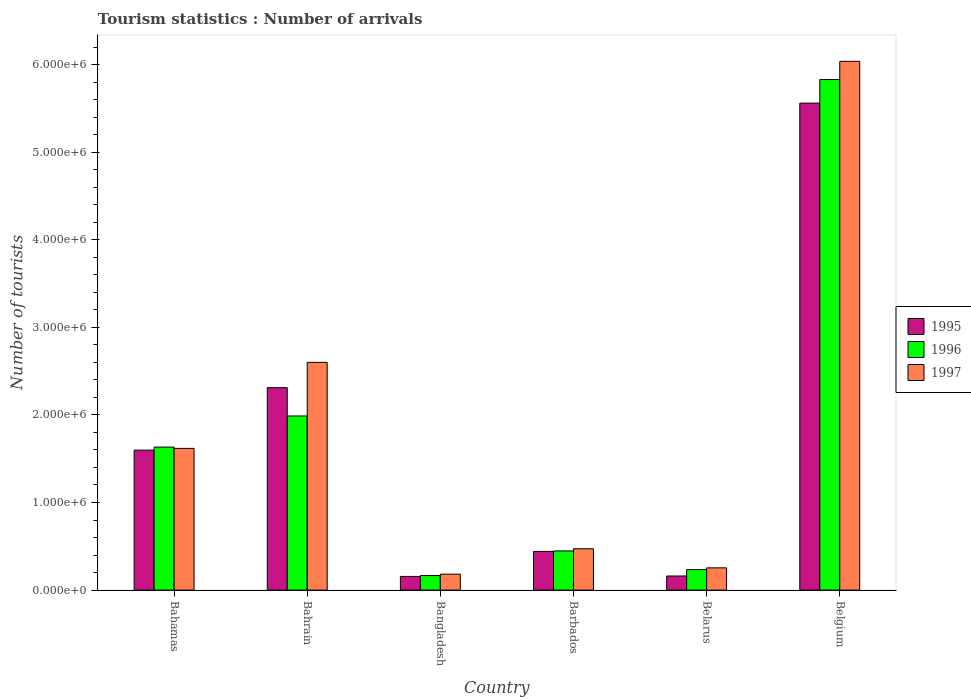Are the number of bars per tick equal to the number of legend labels?
Make the answer very short. Yes. Are the number of bars on each tick of the X-axis equal?
Offer a very short reply. Yes. How many bars are there on the 5th tick from the left?
Your answer should be very brief. 3. What is the label of the 2nd group of bars from the left?
Your response must be concise. Bahrain. In how many cases, is the number of bars for a given country not equal to the number of legend labels?
Offer a very short reply. 0. What is the number of tourist arrivals in 1995 in Bangladesh?
Offer a terse response. 1.56e+05. Across all countries, what is the maximum number of tourist arrivals in 1995?
Offer a terse response. 5.56e+06. Across all countries, what is the minimum number of tourist arrivals in 1996?
Give a very brief answer. 1.66e+05. In which country was the number of tourist arrivals in 1995 minimum?
Your response must be concise. Bangladesh. What is the total number of tourist arrivals in 1997 in the graph?
Your answer should be very brief. 1.12e+07. What is the difference between the number of tourist arrivals in 1997 in Barbados and that in Belgium?
Offer a terse response. -5.56e+06. What is the difference between the number of tourist arrivals in 1995 in Bahrain and the number of tourist arrivals in 1997 in Barbados?
Your response must be concise. 1.84e+06. What is the average number of tourist arrivals in 1997 per country?
Ensure brevity in your answer.  1.86e+06. What is the difference between the number of tourist arrivals of/in 1995 and number of tourist arrivals of/in 1997 in Barbados?
Keep it short and to the point. -3.00e+04. In how many countries, is the number of tourist arrivals in 1996 greater than 5800000?
Provide a short and direct response. 1. What is the ratio of the number of tourist arrivals in 1997 in Barbados to that in Belarus?
Ensure brevity in your answer.  1.86. What is the difference between the highest and the second highest number of tourist arrivals in 1996?
Provide a succinct answer. 4.20e+06. What is the difference between the highest and the lowest number of tourist arrivals in 1996?
Provide a short and direct response. 5.66e+06. What does the 2nd bar from the left in Bahamas represents?
Give a very brief answer. 1996. Is it the case that in every country, the sum of the number of tourist arrivals in 1996 and number of tourist arrivals in 1995 is greater than the number of tourist arrivals in 1997?
Your response must be concise. Yes. How many countries are there in the graph?
Provide a short and direct response. 6. What is the difference between two consecutive major ticks on the Y-axis?
Give a very brief answer. 1.00e+06. Does the graph contain grids?
Your answer should be compact. No. Where does the legend appear in the graph?
Your answer should be compact. Center right. What is the title of the graph?
Offer a very short reply. Tourism statistics : Number of arrivals. Does "1981" appear as one of the legend labels in the graph?
Provide a succinct answer. No. What is the label or title of the Y-axis?
Your response must be concise. Number of tourists. What is the Number of tourists of 1995 in Bahamas?
Provide a short and direct response. 1.60e+06. What is the Number of tourists of 1996 in Bahamas?
Give a very brief answer. 1.63e+06. What is the Number of tourists of 1997 in Bahamas?
Offer a terse response. 1.62e+06. What is the Number of tourists of 1995 in Bahrain?
Provide a succinct answer. 2.31e+06. What is the Number of tourists in 1996 in Bahrain?
Your answer should be compact. 1.99e+06. What is the Number of tourists of 1997 in Bahrain?
Offer a very short reply. 2.60e+06. What is the Number of tourists of 1995 in Bangladesh?
Provide a succinct answer. 1.56e+05. What is the Number of tourists of 1996 in Bangladesh?
Keep it short and to the point. 1.66e+05. What is the Number of tourists in 1997 in Bangladesh?
Your answer should be very brief. 1.82e+05. What is the Number of tourists of 1995 in Barbados?
Your response must be concise. 4.42e+05. What is the Number of tourists in 1996 in Barbados?
Provide a succinct answer. 4.47e+05. What is the Number of tourists in 1997 in Barbados?
Offer a very short reply. 4.72e+05. What is the Number of tourists of 1995 in Belarus?
Ensure brevity in your answer.  1.61e+05. What is the Number of tourists in 1996 in Belarus?
Give a very brief answer. 2.34e+05. What is the Number of tourists in 1997 in Belarus?
Your answer should be very brief. 2.54e+05. What is the Number of tourists in 1995 in Belgium?
Provide a succinct answer. 5.56e+06. What is the Number of tourists of 1996 in Belgium?
Your response must be concise. 5.83e+06. What is the Number of tourists of 1997 in Belgium?
Offer a very short reply. 6.04e+06. Across all countries, what is the maximum Number of tourists in 1995?
Provide a short and direct response. 5.56e+06. Across all countries, what is the maximum Number of tourists of 1996?
Offer a very short reply. 5.83e+06. Across all countries, what is the maximum Number of tourists of 1997?
Provide a succinct answer. 6.04e+06. Across all countries, what is the minimum Number of tourists of 1995?
Offer a very short reply. 1.56e+05. Across all countries, what is the minimum Number of tourists in 1996?
Your answer should be very brief. 1.66e+05. Across all countries, what is the minimum Number of tourists in 1997?
Offer a very short reply. 1.82e+05. What is the total Number of tourists of 1995 in the graph?
Your answer should be compact. 1.02e+07. What is the total Number of tourists of 1996 in the graph?
Offer a very short reply. 1.03e+07. What is the total Number of tourists in 1997 in the graph?
Your answer should be very brief. 1.12e+07. What is the difference between the Number of tourists of 1995 in Bahamas and that in Bahrain?
Keep it short and to the point. -7.13e+05. What is the difference between the Number of tourists of 1996 in Bahamas and that in Bahrain?
Your answer should be compact. -3.55e+05. What is the difference between the Number of tourists in 1997 in Bahamas and that in Bahrain?
Provide a succinct answer. -9.82e+05. What is the difference between the Number of tourists of 1995 in Bahamas and that in Bangladesh?
Give a very brief answer. 1.44e+06. What is the difference between the Number of tourists in 1996 in Bahamas and that in Bangladesh?
Ensure brevity in your answer.  1.47e+06. What is the difference between the Number of tourists of 1997 in Bahamas and that in Bangladesh?
Provide a succinct answer. 1.44e+06. What is the difference between the Number of tourists of 1995 in Bahamas and that in Barbados?
Your answer should be compact. 1.16e+06. What is the difference between the Number of tourists of 1996 in Bahamas and that in Barbados?
Keep it short and to the point. 1.19e+06. What is the difference between the Number of tourists in 1997 in Bahamas and that in Barbados?
Your answer should be very brief. 1.15e+06. What is the difference between the Number of tourists in 1995 in Bahamas and that in Belarus?
Your answer should be compact. 1.44e+06. What is the difference between the Number of tourists of 1996 in Bahamas and that in Belarus?
Your response must be concise. 1.40e+06. What is the difference between the Number of tourists of 1997 in Bahamas and that in Belarus?
Your response must be concise. 1.36e+06. What is the difference between the Number of tourists in 1995 in Bahamas and that in Belgium?
Provide a succinct answer. -3.96e+06. What is the difference between the Number of tourists of 1996 in Bahamas and that in Belgium?
Give a very brief answer. -4.20e+06. What is the difference between the Number of tourists in 1997 in Bahamas and that in Belgium?
Keep it short and to the point. -4.42e+06. What is the difference between the Number of tourists in 1995 in Bahrain and that in Bangladesh?
Offer a terse response. 2.16e+06. What is the difference between the Number of tourists in 1996 in Bahrain and that in Bangladesh?
Your answer should be compact. 1.82e+06. What is the difference between the Number of tourists in 1997 in Bahrain and that in Bangladesh?
Keep it short and to the point. 2.42e+06. What is the difference between the Number of tourists in 1995 in Bahrain and that in Barbados?
Your answer should be compact. 1.87e+06. What is the difference between the Number of tourists in 1996 in Bahrain and that in Barbados?
Keep it short and to the point. 1.54e+06. What is the difference between the Number of tourists in 1997 in Bahrain and that in Barbados?
Offer a terse response. 2.13e+06. What is the difference between the Number of tourists of 1995 in Bahrain and that in Belarus?
Your answer should be compact. 2.15e+06. What is the difference between the Number of tourists of 1996 in Bahrain and that in Belarus?
Your answer should be very brief. 1.75e+06. What is the difference between the Number of tourists of 1997 in Bahrain and that in Belarus?
Provide a succinct answer. 2.35e+06. What is the difference between the Number of tourists in 1995 in Bahrain and that in Belgium?
Give a very brief answer. -3.25e+06. What is the difference between the Number of tourists in 1996 in Bahrain and that in Belgium?
Make the answer very short. -3.84e+06. What is the difference between the Number of tourists of 1997 in Bahrain and that in Belgium?
Give a very brief answer. -3.44e+06. What is the difference between the Number of tourists in 1995 in Bangladesh and that in Barbados?
Make the answer very short. -2.86e+05. What is the difference between the Number of tourists in 1996 in Bangladesh and that in Barbados?
Offer a terse response. -2.81e+05. What is the difference between the Number of tourists of 1995 in Bangladesh and that in Belarus?
Offer a very short reply. -5000. What is the difference between the Number of tourists of 1996 in Bangladesh and that in Belarus?
Provide a succinct answer. -6.80e+04. What is the difference between the Number of tourists of 1997 in Bangladesh and that in Belarus?
Your answer should be very brief. -7.20e+04. What is the difference between the Number of tourists of 1995 in Bangladesh and that in Belgium?
Keep it short and to the point. -5.40e+06. What is the difference between the Number of tourists in 1996 in Bangladesh and that in Belgium?
Make the answer very short. -5.66e+06. What is the difference between the Number of tourists of 1997 in Bangladesh and that in Belgium?
Your answer should be very brief. -5.86e+06. What is the difference between the Number of tourists of 1995 in Barbados and that in Belarus?
Provide a short and direct response. 2.81e+05. What is the difference between the Number of tourists in 1996 in Barbados and that in Belarus?
Your response must be concise. 2.13e+05. What is the difference between the Number of tourists in 1997 in Barbados and that in Belarus?
Make the answer very short. 2.18e+05. What is the difference between the Number of tourists in 1995 in Barbados and that in Belgium?
Provide a succinct answer. -5.12e+06. What is the difference between the Number of tourists in 1996 in Barbados and that in Belgium?
Your response must be concise. -5.38e+06. What is the difference between the Number of tourists of 1997 in Barbados and that in Belgium?
Ensure brevity in your answer.  -5.56e+06. What is the difference between the Number of tourists in 1995 in Belarus and that in Belgium?
Provide a succinct answer. -5.40e+06. What is the difference between the Number of tourists of 1996 in Belarus and that in Belgium?
Offer a very short reply. -5.60e+06. What is the difference between the Number of tourists of 1997 in Belarus and that in Belgium?
Ensure brevity in your answer.  -5.78e+06. What is the difference between the Number of tourists in 1995 in Bahamas and the Number of tourists in 1996 in Bahrain?
Your response must be concise. -3.90e+05. What is the difference between the Number of tourists of 1995 in Bahamas and the Number of tourists of 1997 in Bahrain?
Offer a terse response. -1.00e+06. What is the difference between the Number of tourists in 1996 in Bahamas and the Number of tourists in 1997 in Bahrain?
Your answer should be compact. -9.67e+05. What is the difference between the Number of tourists in 1995 in Bahamas and the Number of tourists in 1996 in Bangladesh?
Keep it short and to the point. 1.43e+06. What is the difference between the Number of tourists of 1995 in Bahamas and the Number of tourists of 1997 in Bangladesh?
Your answer should be compact. 1.42e+06. What is the difference between the Number of tourists of 1996 in Bahamas and the Number of tourists of 1997 in Bangladesh?
Keep it short and to the point. 1.45e+06. What is the difference between the Number of tourists of 1995 in Bahamas and the Number of tourists of 1996 in Barbados?
Offer a very short reply. 1.15e+06. What is the difference between the Number of tourists in 1995 in Bahamas and the Number of tourists in 1997 in Barbados?
Provide a succinct answer. 1.13e+06. What is the difference between the Number of tourists in 1996 in Bahamas and the Number of tourists in 1997 in Barbados?
Your response must be concise. 1.16e+06. What is the difference between the Number of tourists of 1995 in Bahamas and the Number of tourists of 1996 in Belarus?
Give a very brief answer. 1.36e+06. What is the difference between the Number of tourists in 1995 in Bahamas and the Number of tourists in 1997 in Belarus?
Offer a very short reply. 1.34e+06. What is the difference between the Number of tourists of 1996 in Bahamas and the Number of tourists of 1997 in Belarus?
Provide a succinct answer. 1.38e+06. What is the difference between the Number of tourists of 1995 in Bahamas and the Number of tourists of 1996 in Belgium?
Your answer should be compact. -4.23e+06. What is the difference between the Number of tourists of 1995 in Bahamas and the Number of tourists of 1997 in Belgium?
Your answer should be very brief. -4.44e+06. What is the difference between the Number of tourists of 1996 in Bahamas and the Number of tourists of 1997 in Belgium?
Your response must be concise. -4.40e+06. What is the difference between the Number of tourists of 1995 in Bahrain and the Number of tourists of 1996 in Bangladesh?
Make the answer very short. 2.14e+06. What is the difference between the Number of tourists of 1995 in Bahrain and the Number of tourists of 1997 in Bangladesh?
Your response must be concise. 2.13e+06. What is the difference between the Number of tourists in 1996 in Bahrain and the Number of tourists in 1997 in Bangladesh?
Provide a succinct answer. 1.81e+06. What is the difference between the Number of tourists of 1995 in Bahrain and the Number of tourists of 1996 in Barbados?
Offer a terse response. 1.86e+06. What is the difference between the Number of tourists in 1995 in Bahrain and the Number of tourists in 1997 in Barbados?
Keep it short and to the point. 1.84e+06. What is the difference between the Number of tourists of 1996 in Bahrain and the Number of tourists of 1997 in Barbados?
Keep it short and to the point. 1.52e+06. What is the difference between the Number of tourists in 1995 in Bahrain and the Number of tourists in 1996 in Belarus?
Provide a succinct answer. 2.08e+06. What is the difference between the Number of tourists in 1995 in Bahrain and the Number of tourists in 1997 in Belarus?
Offer a very short reply. 2.06e+06. What is the difference between the Number of tourists of 1996 in Bahrain and the Number of tourists of 1997 in Belarus?
Provide a succinct answer. 1.73e+06. What is the difference between the Number of tourists in 1995 in Bahrain and the Number of tourists in 1996 in Belgium?
Keep it short and to the point. -3.52e+06. What is the difference between the Number of tourists of 1995 in Bahrain and the Number of tourists of 1997 in Belgium?
Make the answer very short. -3.73e+06. What is the difference between the Number of tourists in 1996 in Bahrain and the Number of tourists in 1997 in Belgium?
Ensure brevity in your answer.  -4.05e+06. What is the difference between the Number of tourists in 1995 in Bangladesh and the Number of tourists in 1996 in Barbados?
Provide a short and direct response. -2.91e+05. What is the difference between the Number of tourists of 1995 in Bangladesh and the Number of tourists of 1997 in Barbados?
Your answer should be very brief. -3.16e+05. What is the difference between the Number of tourists in 1996 in Bangladesh and the Number of tourists in 1997 in Barbados?
Provide a succinct answer. -3.06e+05. What is the difference between the Number of tourists in 1995 in Bangladesh and the Number of tourists in 1996 in Belarus?
Give a very brief answer. -7.80e+04. What is the difference between the Number of tourists in 1995 in Bangladesh and the Number of tourists in 1997 in Belarus?
Make the answer very short. -9.80e+04. What is the difference between the Number of tourists in 1996 in Bangladesh and the Number of tourists in 1997 in Belarus?
Keep it short and to the point. -8.80e+04. What is the difference between the Number of tourists in 1995 in Bangladesh and the Number of tourists in 1996 in Belgium?
Make the answer very short. -5.67e+06. What is the difference between the Number of tourists of 1995 in Bangladesh and the Number of tourists of 1997 in Belgium?
Make the answer very short. -5.88e+06. What is the difference between the Number of tourists of 1996 in Bangladesh and the Number of tourists of 1997 in Belgium?
Keep it short and to the point. -5.87e+06. What is the difference between the Number of tourists in 1995 in Barbados and the Number of tourists in 1996 in Belarus?
Give a very brief answer. 2.08e+05. What is the difference between the Number of tourists in 1995 in Barbados and the Number of tourists in 1997 in Belarus?
Provide a short and direct response. 1.88e+05. What is the difference between the Number of tourists of 1996 in Barbados and the Number of tourists of 1997 in Belarus?
Your response must be concise. 1.93e+05. What is the difference between the Number of tourists of 1995 in Barbados and the Number of tourists of 1996 in Belgium?
Keep it short and to the point. -5.39e+06. What is the difference between the Number of tourists of 1995 in Barbados and the Number of tourists of 1997 in Belgium?
Your response must be concise. -5.60e+06. What is the difference between the Number of tourists of 1996 in Barbados and the Number of tourists of 1997 in Belgium?
Your response must be concise. -5.59e+06. What is the difference between the Number of tourists of 1995 in Belarus and the Number of tourists of 1996 in Belgium?
Offer a very short reply. -5.67e+06. What is the difference between the Number of tourists of 1995 in Belarus and the Number of tourists of 1997 in Belgium?
Your answer should be very brief. -5.88e+06. What is the difference between the Number of tourists in 1996 in Belarus and the Number of tourists in 1997 in Belgium?
Provide a succinct answer. -5.80e+06. What is the average Number of tourists in 1995 per country?
Give a very brief answer. 1.70e+06. What is the average Number of tourists in 1996 per country?
Provide a short and direct response. 1.72e+06. What is the average Number of tourists of 1997 per country?
Offer a terse response. 1.86e+06. What is the difference between the Number of tourists in 1995 and Number of tourists in 1996 in Bahamas?
Keep it short and to the point. -3.50e+04. What is the difference between the Number of tourists of 1995 and Number of tourists of 1997 in Bahamas?
Keep it short and to the point. -2.00e+04. What is the difference between the Number of tourists of 1996 and Number of tourists of 1997 in Bahamas?
Offer a very short reply. 1.50e+04. What is the difference between the Number of tourists of 1995 and Number of tourists of 1996 in Bahrain?
Your answer should be compact. 3.23e+05. What is the difference between the Number of tourists of 1995 and Number of tourists of 1997 in Bahrain?
Offer a very short reply. -2.89e+05. What is the difference between the Number of tourists in 1996 and Number of tourists in 1997 in Bahrain?
Your response must be concise. -6.12e+05. What is the difference between the Number of tourists of 1995 and Number of tourists of 1997 in Bangladesh?
Your response must be concise. -2.60e+04. What is the difference between the Number of tourists of 1996 and Number of tourists of 1997 in Bangladesh?
Make the answer very short. -1.60e+04. What is the difference between the Number of tourists in 1995 and Number of tourists in 1996 in Barbados?
Make the answer very short. -5000. What is the difference between the Number of tourists of 1996 and Number of tourists of 1997 in Barbados?
Keep it short and to the point. -2.50e+04. What is the difference between the Number of tourists of 1995 and Number of tourists of 1996 in Belarus?
Ensure brevity in your answer.  -7.30e+04. What is the difference between the Number of tourists of 1995 and Number of tourists of 1997 in Belarus?
Make the answer very short. -9.30e+04. What is the difference between the Number of tourists in 1995 and Number of tourists in 1996 in Belgium?
Your response must be concise. -2.69e+05. What is the difference between the Number of tourists of 1995 and Number of tourists of 1997 in Belgium?
Your answer should be compact. -4.77e+05. What is the difference between the Number of tourists of 1996 and Number of tourists of 1997 in Belgium?
Provide a short and direct response. -2.08e+05. What is the ratio of the Number of tourists in 1995 in Bahamas to that in Bahrain?
Offer a very short reply. 0.69. What is the ratio of the Number of tourists in 1996 in Bahamas to that in Bahrain?
Make the answer very short. 0.82. What is the ratio of the Number of tourists of 1997 in Bahamas to that in Bahrain?
Offer a very short reply. 0.62. What is the ratio of the Number of tourists in 1995 in Bahamas to that in Bangladesh?
Offer a very short reply. 10.24. What is the ratio of the Number of tourists of 1996 in Bahamas to that in Bangladesh?
Offer a very short reply. 9.84. What is the ratio of the Number of tourists of 1997 in Bahamas to that in Bangladesh?
Your response must be concise. 8.89. What is the ratio of the Number of tourists in 1995 in Bahamas to that in Barbados?
Your answer should be very brief. 3.62. What is the ratio of the Number of tourists in 1996 in Bahamas to that in Barbados?
Keep it short and to the point. 3.65. What is the ratio of the Number of tourists of 1997 in Bahamas to that in Barbados?
Give a very brief answer. 3.43. What is the ratio of the Number of tourists in 1995 in Bahamas to that in Belarus?
Your answer should be very brief. 9.93. What is the ratio of the Number of tourists of 1996 in Bahamas to that in Belarus?
Your answer should be compact. 6.98. What is the ratio of the Number of tourists in 1997 in Bahamas to that in Belarus?
Make the answer very short. 6.37. What is the ratio of the Number of tourists in 1995 in Bahamas to that in Belgium?
Make the answer very short. 0.29. What is the ratio of the Number of tourists in 1996 in Bahamas to that in Belgium?
Offer a terse response. 0.28. What is the ratio of the Number of tourists of 1997 in Bahamas to that in Belgium?
Your answer should be compact. 0.27. What is the ratio of the Number of tourists of 1995 in Bahrain to that in Bangladesh?
Your answer should be compact. 14.81. What is the ratio of the Number of tourists in 1996 in Bahrain to that in Bangladesh?
Your answer should be very brief. 11.98. What is the ratio of the Number of tourists in 1997 in Bahrain to that in Bangladesh?
Offer a very short reply. 14.29. What is the ratio of the Number of tourists in 1995 in Bahrain to that in Barbados?
Make the answer very short. 5.23. What is the ratio of the Number of tourists of 1996 in Bahrain to that in Barbados?
Your answer should be compact. 4.45. What is the ratio of the Number of tourists in 1997 in Bahrain to that in Barbados?
Keep it short and to the point. 5.51. What is the ratio of the Number of tourists of 1995 in Bahrain to that in Belarus?
Make the answer very short. 14.35. What is the ratio of the Number of tourists of 1996 in Bahrain to that in Belarus?
Offer a very short reply. 8.5. What is the ratio of the Number of tourists in 1997 in Bahrain to that in Belarus?
Provide a short and direct response. 10.24. What is the ratio of the Number of tourists of 1995 in Bahrain to that in Belgium?
Ensure brevity in your answer.  0.42. What is the ratio of the Number of tourists of 1996 in Bahrain to that in Belgium?
Give a very brief answer. 0.34. What is the ratio of the Number of tourists of 1997 in Bahrain to that in Belgium?
Keep it short and to the point. 0.43. What is the ratio of the Number of tourists in 1995 in Bangladesh to that in Barbados?
Your answer should be compact. 0.35. What is the ratio of the Number of tourists of 1996 in Bangladesh to that in Barbados?
Your answer should be compact. 0.37. What is the ratio of the Number of tourists of 1997 in Bangladesh to that in Barbados?
Offer a very short reply. 0.39. What is the ratio of the Number of tourists of 1995 in Bangladesh to that in Belarus?
Keep it short and to the point. 0.97. What is the ratio of the Number of tourists of 1996 in Bangladesh to that in Belarus?
Ensure brevity in your answer.  0.71. What is the ratio of the Number of tourists of 1997 in Bangladesh to that in Belarus?
Provide a short and direct response. 0.72. What is the ratio of the Number of tourists in 1995 in Bangladesh to that in Belgium?
Offer a very short reply. 0.03. What is the ratio of the Number of tourists in 1996 in Bangladesh to that in Belgium?
Give a very brief answer. 0.03. What is the ratio of the Number of tourists of 1997 in Bangladesh to that in Belgium?
Ensure brevity in your answer.  0.03. What is the ratio of the Number of tourists of 1995 in Barbados to that in Belarus?
Your answer should be very brief. 2.75. What is the ratio of the Number of tourists of 1996 in Barbados to that in Belarus?
Offer a terse response. 1.91. What is the ratio of the Number of tourists in 1997 in Barbados to that in Belarus?
Your answer should be compact. 1.86. What is the ratio of the Number of tourists of 1995 in Barbados to that in Belgium?
Provide a short and direct response. 0.08. What is the ratio of the Number of tourists of 1996 in Barbados to that in Belgium?
Offer a terse response. 0.08. What is the ratio of the Number of tourists of 1997 in Barbados to that in Belgium?
Make the answer very short. 0.08. What is the ratio of the Number of tourists in 1995 in Belarus to that in Belgium?
Offer a very short reply. 0.03. What is the ratio of the Number of tourists in 1996 in Belarus to that in Belgium?
Your answer should be compact. 0.04. What is the ratio of the Number of tourists in 1997 in Belarus to that in Belgium?
Provide a succinct answer. 0.04. What is the difference between the highest and the second highest Number of tourists of 1995?
Offer a terse response. 3.25e+06. What is the difference between the highest and the second highest Number of tourists of 1996?
Give a very brief answer. 3.84e+06. What is the difference between the highest and the second highest Number of tourists in 1997?
Make the answer very short. 3.44e+06. What is the difference between the highest and the lowest Number of tourists of 1995?
Your response must be concise. 5.40e+06. What is the difference between the highest and the lowest Number of tourists of 1996?
Provide a succinct answer. 5.66e+06. What is the difference between the highest and the lowest Number of tourists in 1997?
Provide a succinct answer. 5.86e+06. 